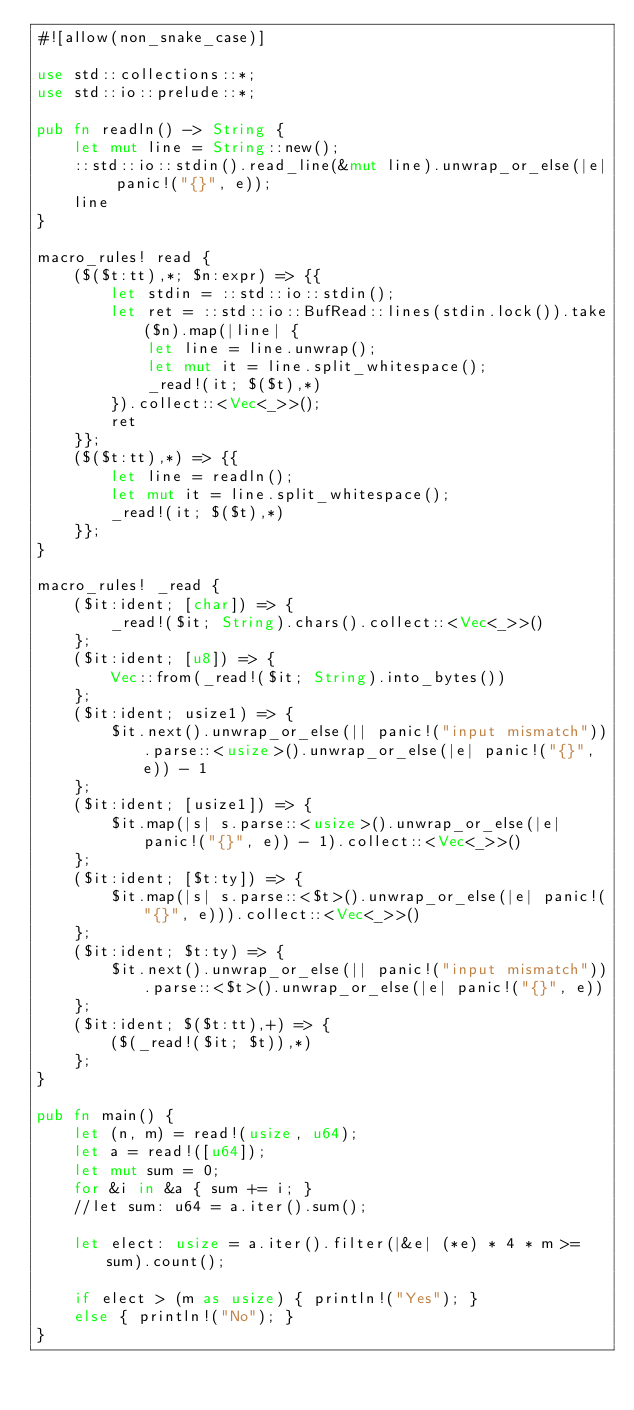Convert code to text. <code><loc_0><loc_0><loc_500><loc_500><_Rust_>#![allow(non_snake_case)]
 
use std::collections::*;
use std::io::prelude::*;

pub fn readln() -> String {
	let mut line = String::new();
	::std::io::stdin().read_line(&mut line).unwrap_or_else(|e| panic!("{}", e));
	line
}
 
macro_rules! read {
	($($t:tt),*; $n:expr) => {{
		let stdin = ::std::io::stdin();
		let ret = ::std::io::BufRead::lines(stdin.lock()).take($n).map(|line| {
			let line = line.unwrap();
			let mut it = line.split_whitespace();
			_read!(it; $($t),*)
		}).collect::<Vec<_>>();
		ret
	}};
	($($t:tt),*) => {{
		let line = readln();
		let mut it = line.split_whitespace();
		_read!(it; $($t),*)
	}};
}
 
macro_rules! _read {
	($it:ident; [char]) => {
		_read!($it; String).chars().collect::<Vec<_>>()
	};
	($it:ident; [u8]) => {
		Vec::from(_read!($it; String).into_bytes())
	};
	($it:ident; usize1) => {
		$it.next().unwrap_or_else(|| panic!("input mismatch")).parse::<usize>().unwrap_or_else(|e| panic!("{}", e)) - 1
	};
	($it:ident; [usize1]) => {
		$it.map(|s| s.parse::<usize>().unwrap_or_else(|e| panic!("{}", e)) - 1).collect::<Vec<_>>()
	};
	($it:ident; [$t:ty]) => {
		$it.map(|s| s.parse::<$t>().unwrap_or_else(|e| panic!("{}", e))).collect::<Vec<_>>()
	};
	($it:ident; $t:ty) => {
		$it.next().unwrap_or_else(|| panic!("input mismatch")).parse::<$t>().unwrap_or_else(|e| panic!("{}", e))
	};
	($it:ident; $($t:tt),+) => {
		($(_read!($it; $t)),*)
	};
}
 
pub fn main() {
	let (n, m) = read!(usize, u64);
	let a = read!([u64]);
	let mut sum = 0;
	for &i in &a { sum += i; }
	//let sum: u64 = a.iter().sum();

	let elect: usize = a.iter().filter(|&e| (*e) * 4 * m >= sum).count();

	if elect > (m as usize) { println!("Yes"); }
	else { println!("No"); }
}
 </code> 